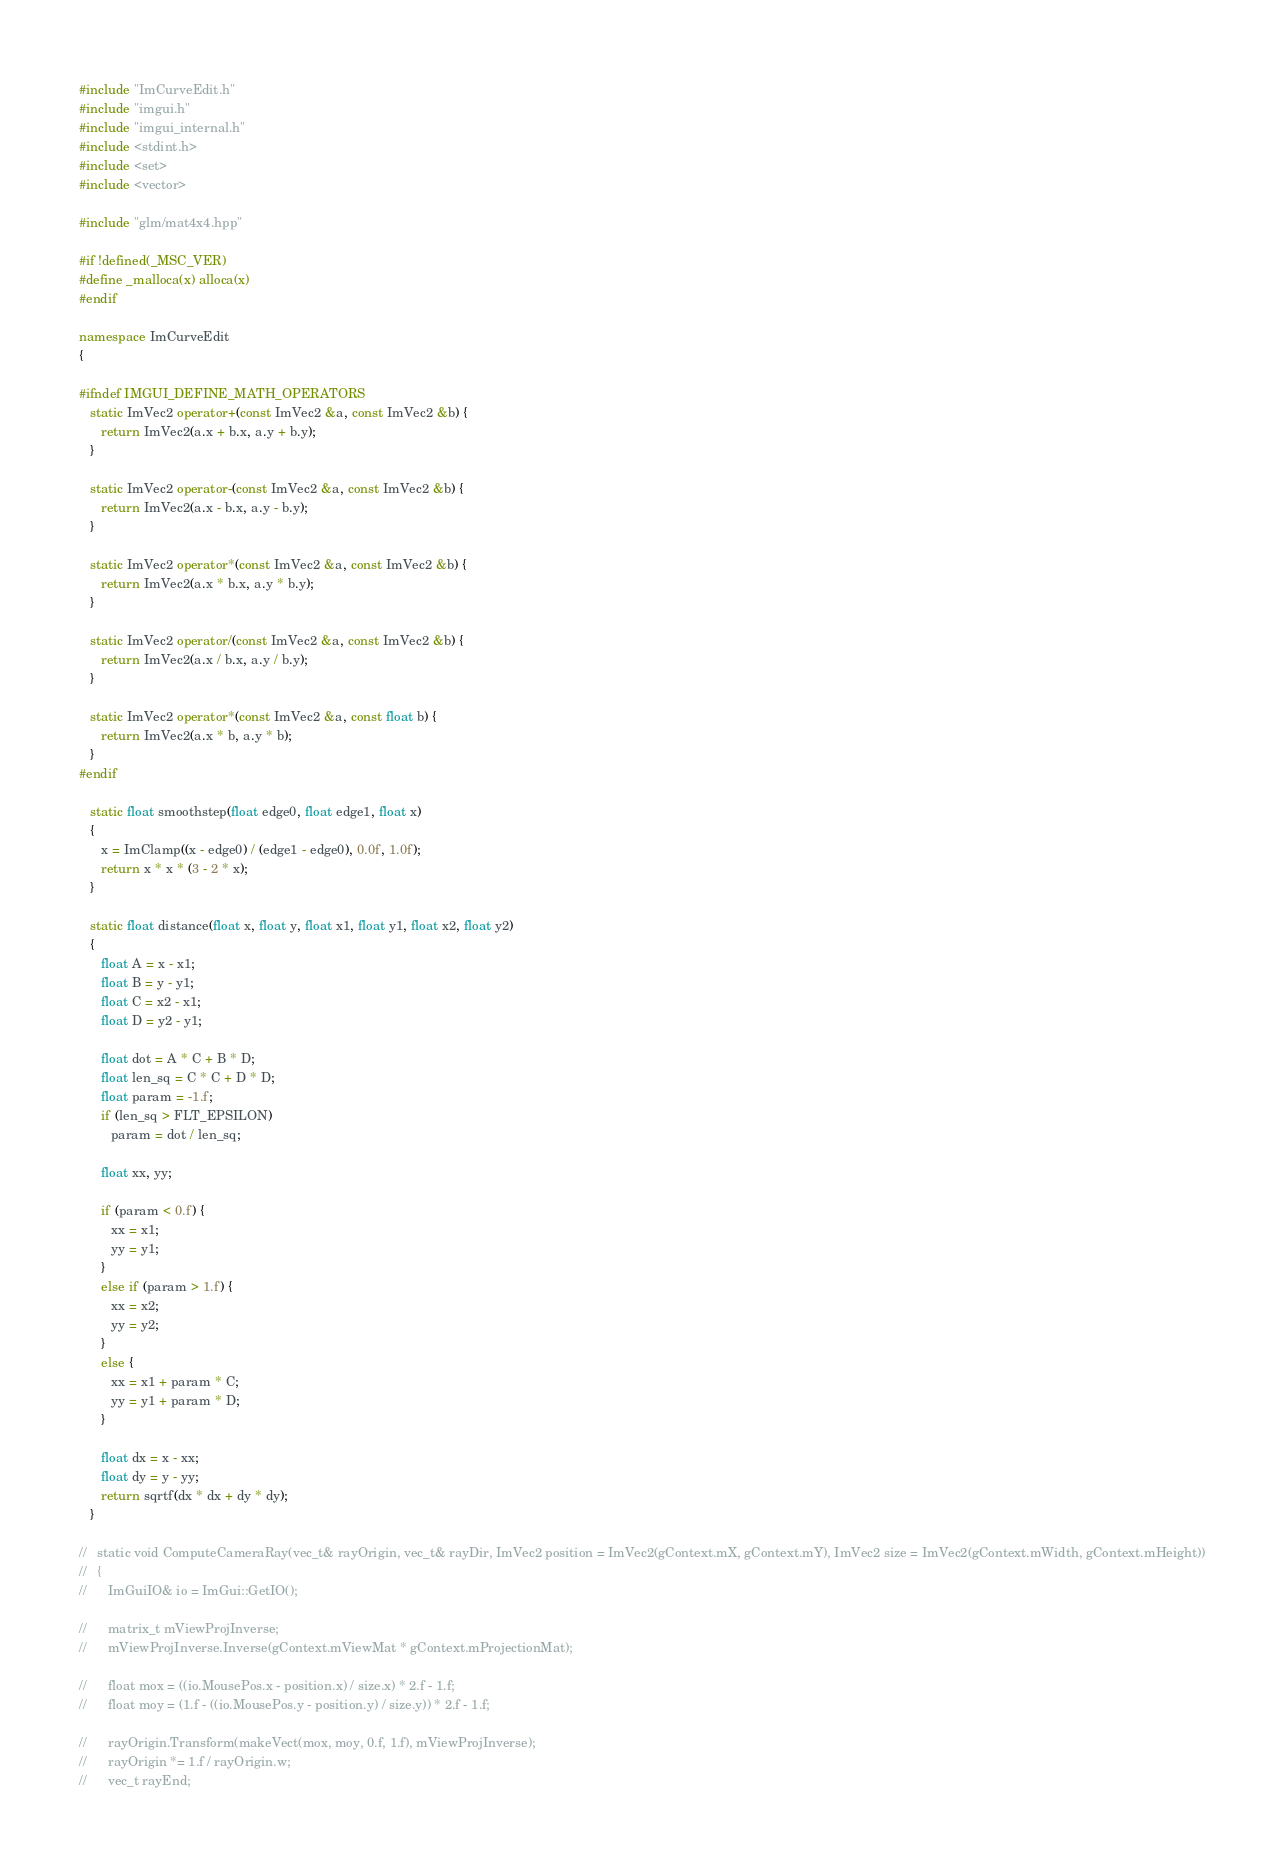<code> <loc_0><loc_0><loc_500><loc_500><_C++_>#include "ImCurveEdit.h"
#include "imgui.h"
#include "imgui_internal.h"
#include <stdint.h>
#include <set>
#include <vector>

#include "glm/mat4x4.hpp"

#if !defined(_MSC_VER)
#define _malloca(x) alloca(x)
#endif

namespace ImCurveEdit
{

#ifndef IMGUI_DEFINE_MATH_OPERATORS
   static ImVec2 operator+(const ImVec2 &a, const ImVec2 &b) {
      return ImVec2(a.x + b.x, a.y + b.y);
   }

   static ImVec2 operator-(const ImVec2 &a, const ImVec2 &b) {
      return ImVec2(a.x - b.x, a.y - b.y);
   }

   static ImVec2 operator*(const ImVec2 &a, const ImVec2 &b) {
      return ImVec2(a.x * b.x, a.y * b.y);
   }

   static ImVec2 operator/(const ImVec2 &a, const ImVec2 &b) {
      return ImVec2(a.x / b.x, a.y / b.y);
   }

   static ImVec2 operator*(const ImVec2 &a, const float b) {
      return ImVec2(a.x * b, a.y * b);
   }
#endif

   static float smoothstep(float edge0, float edge1, float x)
   {
      x = ImClamp((x - edge0) / (edge1 - edge0), 0.0f, 1.0f);
      return x * x * (3 - 2 * x);
   }

   static float distance(float x, float y, float x1, float y1, float x2, float y2)
   {
      float A = x - x1;
      float B = y - y1;
      float C = x2 - x1;
      float D = y2 - y1;

      float dot = A * C + B * D;
      float len_sq = C * C + D * D;
      float param = -1.f;
      if (len_sq > FLT_EPSILON)
         param = dot / len_sq;

      float xx, yy;

      if (param < 0.f) {
         xx = x1;
         yy = y1;
      }
      else if (param > 1.f) {
         xx = x2;
         yy = y2;
      }
      else {
         xx = x1 + param * C;
         yy = y1 + param * D;
      }

      float dx = x - xx;
      float dy = y - yy;
      return sqrtf(dx * dx + dy * dy);
   }

//   static void ComputeCameraRay(vec_t& rayOrigin, vec_t& rayDir, ImVec2 position = ImVec2(gContext.mX, gContext.mY), ImVec2 size = ImVec2(gContext.mWidth, gContext.mHeight))
//   {
//      ImGuiIO& io = ImGui::GetIO();

//      matrix_t mViewProjInverse;
//      mViewProjInverse.Inverse(gContext.mViewMat * gContext.mProjectionMat);

//      float mox = ((io.MousePos.x - position.x) / size.x) * 2.f - 1.f;
//      float moy = (1.f - ((io.MousePos.y - position.y) / size.y)) * 2.f - 1.f;

//      rayOrigin.Transform(makeVect(mox, moy, 0.f, 1.f), mViewProjInverse);
//      rayOrigin *= 1.f / rayOrigin.w;
//      vec_t rayEnd;</code> 